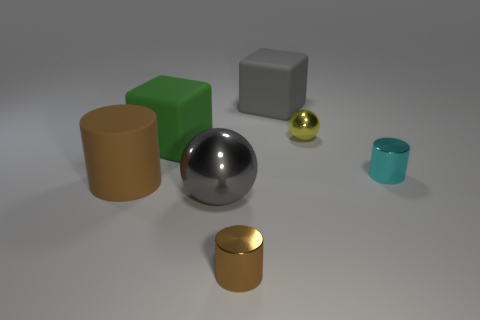Subtract all metal cylinders. How many cylinders are left? 1 Add 3 big green rubber things. How many objects exist? 10 Subtract all gray balls. How many balls are left? 1 Subtract all cubes. How many objects are left? 5 Add 7 large green shiny cylinders. How many large green shiny cylinders exist? 7 Subtract 0 yellow blocks. How many objects are left? 7 Subtract 1 cubes. How many cubes are left? 1 Subtract all yellow cylinders. Subtract all purple spheres. How many cylinders are left? 3 Subtract all blue spheres. How many green blocks are left? 1 Subtract all large gray balls. Subtract all yellow spheres. How many objects are left? 5 